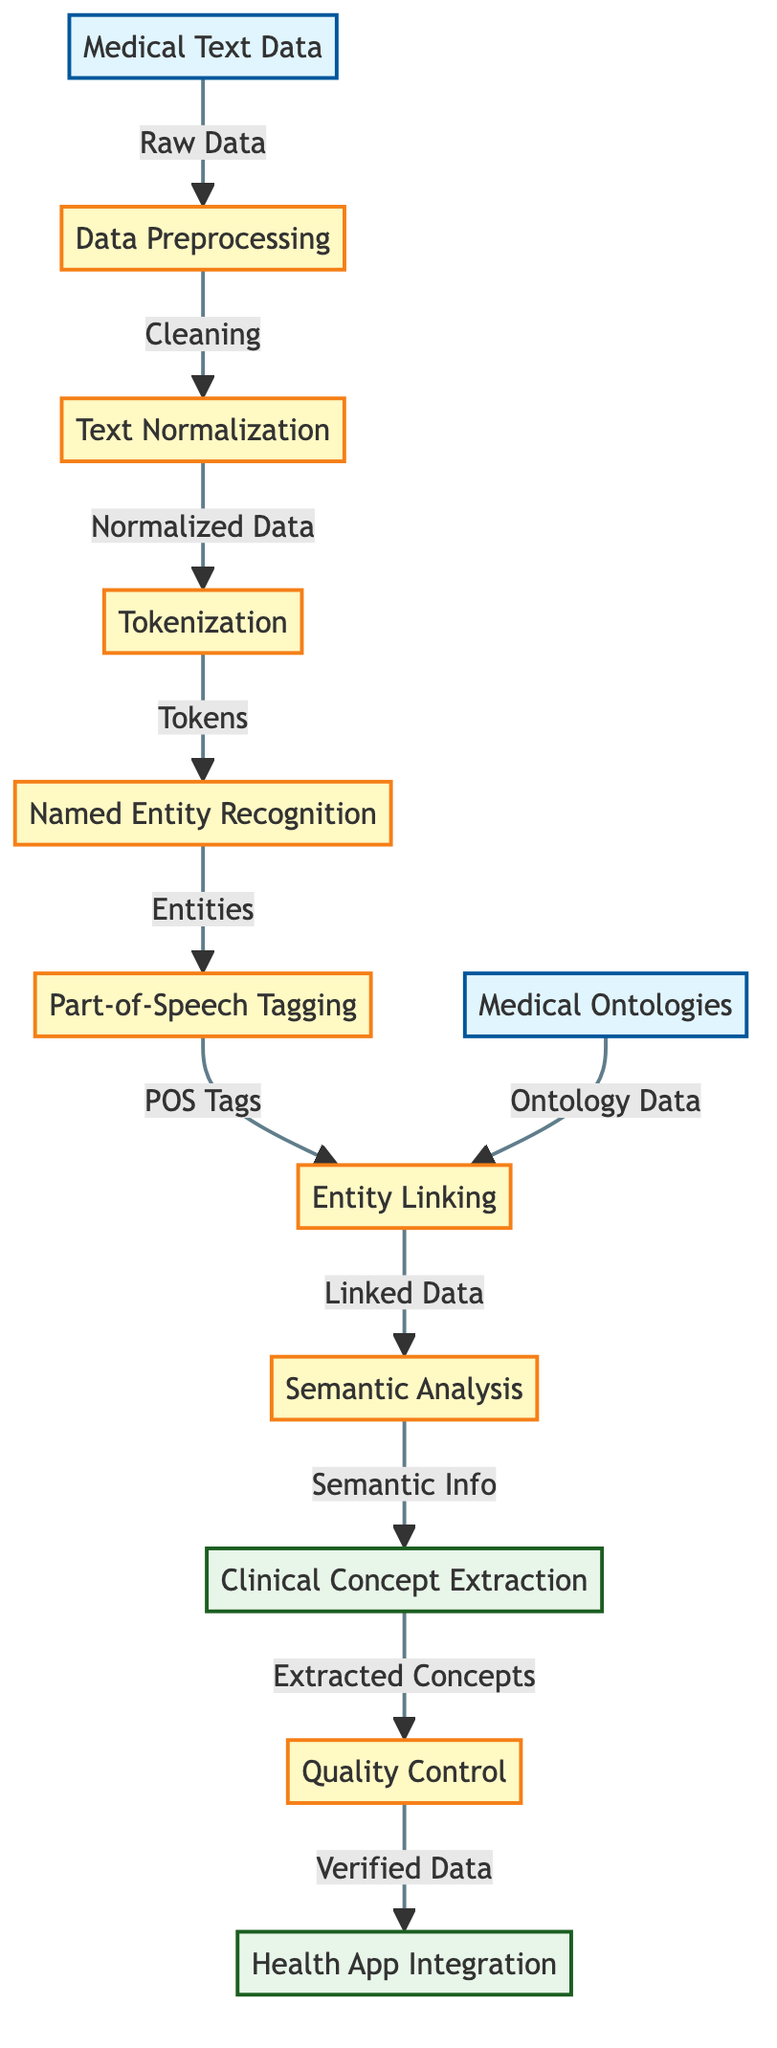What is the first input node in the diagram? The first input node in the diagram is labeled "Medical Text Data." This can be easily identified as it is the starting point of the flowchart, connected to the first processing step.
Answer: Medical Text Data How many processing nodes are there in total? By counting all the nodes designated as processing steps in the diagram, we find that there are seven processing nodes, which include Data Preprocessing, Text Normalization, Tokenization, Named Entity Recognition, Part-of-Speech Tagging, Entity Linking, and Quality Control.
Answer: Seven What is the output of the process after Semantic Analysis? The output after the Semantic Analysis step is "Clinical Concept Extraction." This is indicated as the next node following Semantic Analysis in the flow of the diagram.
Answer: Clinical Concept Extraction Which node follows Tokenization in the diagram? The node that directly follows Tokenization is "Named Entity Recognition." This can be deduced by looking at the arrows that connect these two nodes in the flowchart.
Answer: Named Entity Recognition What type of data is linked with Entity Linking? Entity Linking is connected to two types of data: the output from the Named Entity Recognition and the input from Medical Ontologies. This requires observing the arrows leading into Entity Linking from those two earlier steps.
Answer: Linked Data How does the flowchart ensure quality control in medical text processing? The flowchart includes a specific processing step labeled "Quality Control" that follows "Clinical Concept Extraction." This indicates that the output from Clinical Concept Extraction is verified before it is integrated into health apps.
Answer: Quality Control What is the relation between Part-of-Speech Tagging and Entity Linking? The arrow from Part-of-Speech Tagging to Entity Linking indicates that the output from Part-of-Speech Tagging, which is "POS Tags," is an input for Entity Linking, showing a direct connection between these two processes.
Answer: Entity Linking Which input node provides data for the Entity Linking process? The input node that provides data for the Entity Linking process is "Medical Ontologies," as indicated by the direct link flowing into the Entity Linking node from the Medical Ontologies node.
Answer: Medical Ontologies 